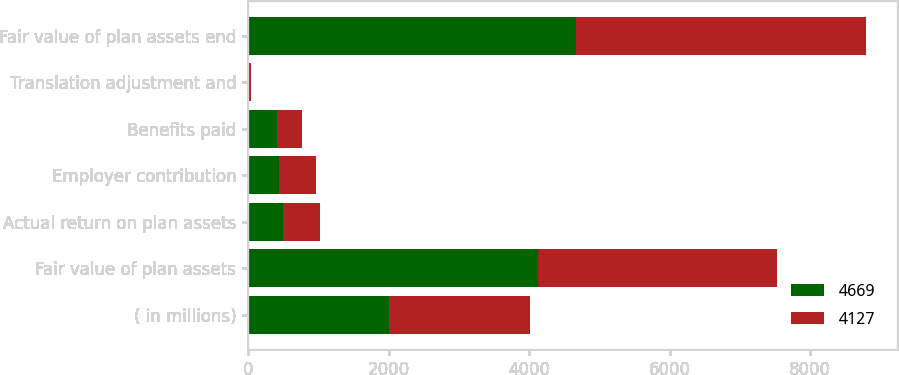Convert chart to OTSL. <chart><loc_0><loc_0><loc_500><loc_500><stacked_bar_chart><ecel><fcel>( in millions)<fcel>Fair value of plan assets<fcel>Actual return on plan assets<fcel>Employer contribution<fcel>Benefits paid<fcel>Translation adjustment and<fcel>Fair value of plan assets end<nl><fcel>4669<fcel>2010<fcel>4127<fcel>496<fcel>443<fcel>407<fcel>10<fcel>4669<nl><fcel>4127<fcel>2009<fcel>3399<fcel>531<fcel>526<fcel>356<fcel>27<fcel>4127<nl></chart> 